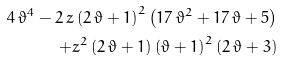<formula> <loc_0><loc_0><loc_500><loc_500>4 \, { \vartheta } ^ { 4 } - 2 \, z \left ( 2 \, \vartheta + 1 \right ) ^ { 2 } \left ( 1 7 \, { \vartheta } ^ { 2 } + 1 7 \, \vartheta + 5 \right ) \\ + { z } ^ { 2 } \left ( 2 \, \vartheta + 1 \right ) \left ( \vartheta + 1 \right ) ^ { 2 } \left ( 2 \, \vartheta + 3 \right )</formula> 